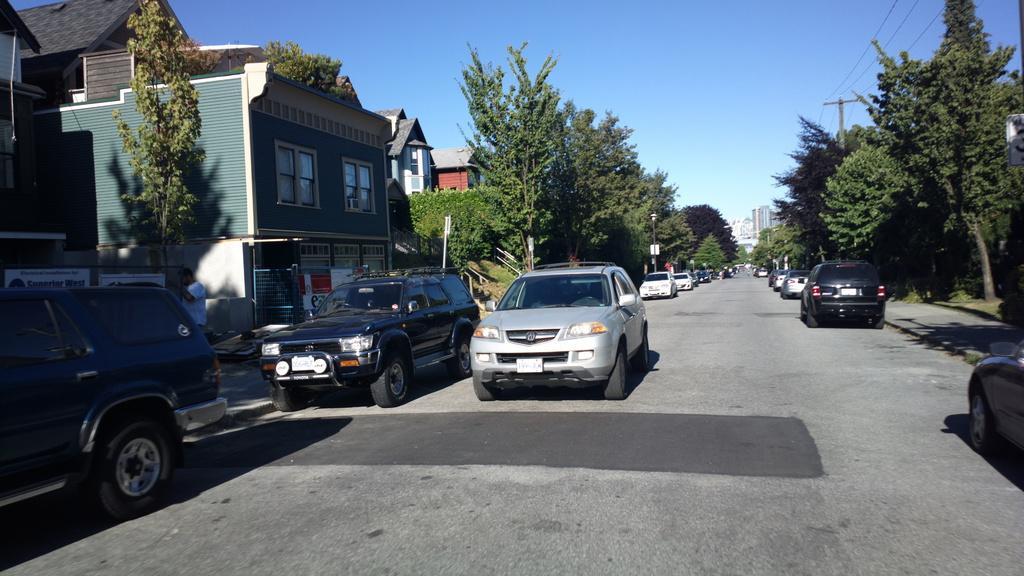In one or two sentences, can you explain what this image depicts? In the center of the image we can see a few vehicles on the road. In the background, we can see the sky, buildings, windows, trees, poles, wires, one person is standing and a few other objects. 